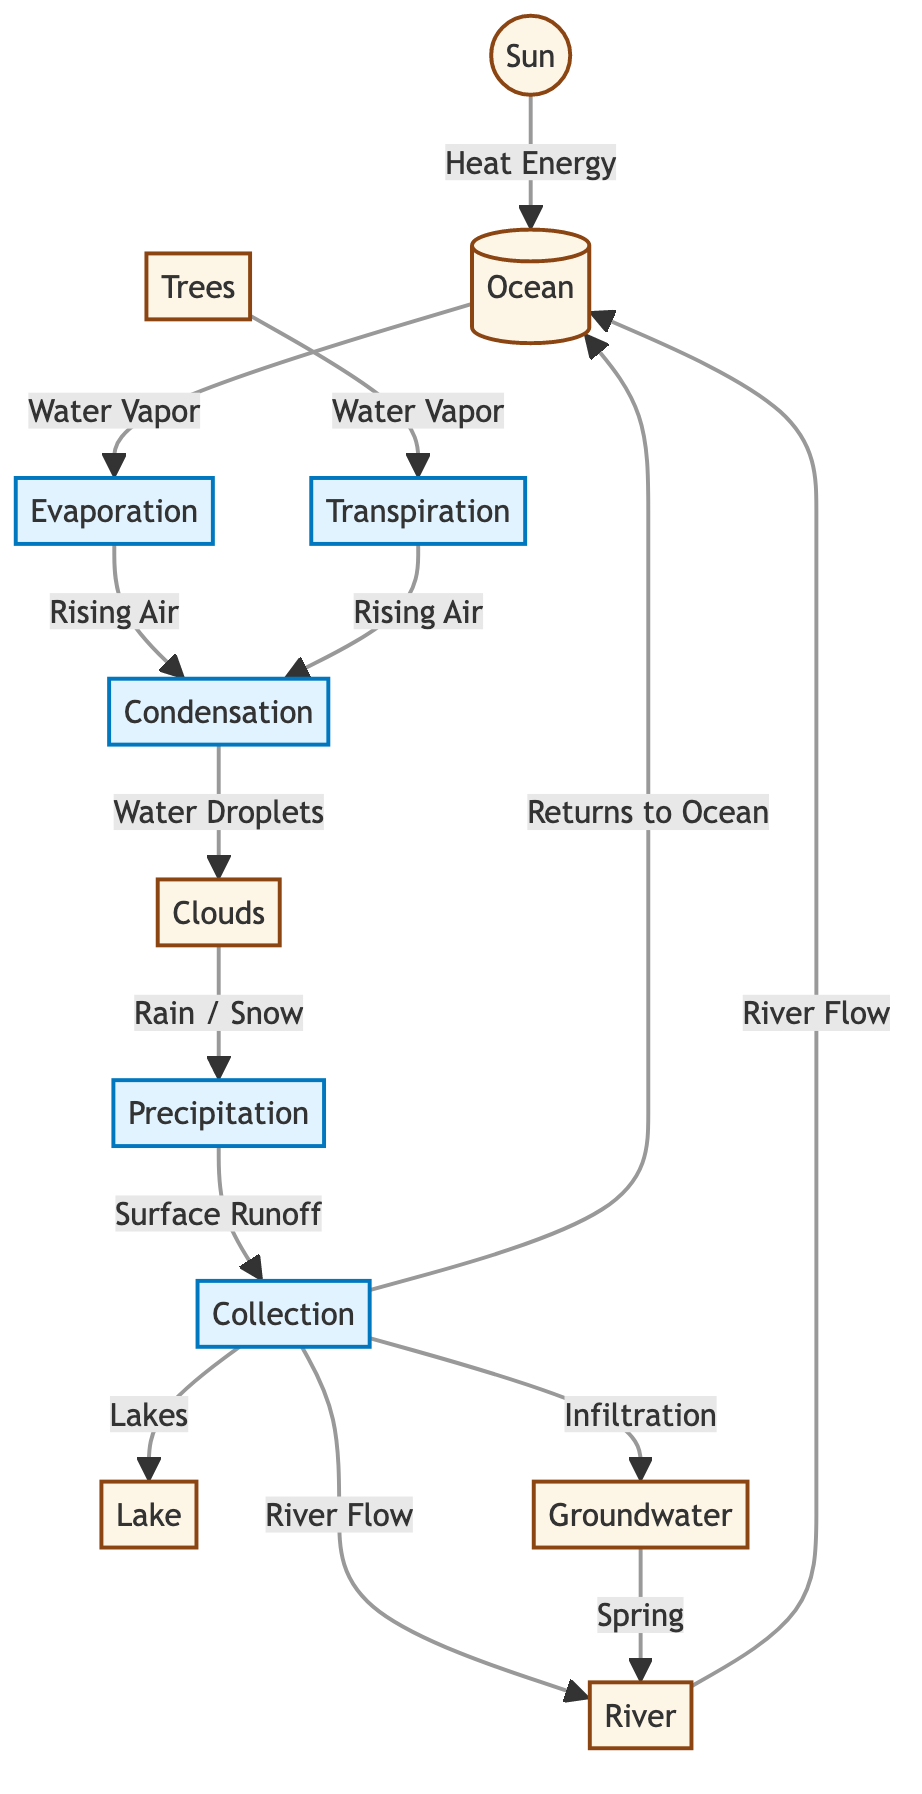What process follows evaporation? According to the diagram, evaporation is followed by condensation, which is indicated by the arrow connecting the two processes.
Answer: condensation How many elements are directly connected to the collection process? The collection process has four direct connections, as seen by the arrows leading to the river, lake, ocean, and groundwater.
Answer: four What does precipitation result in? The precipitation process results in surface runoff, which is denoted by the arrow leading from precipitation to the collection node, indicating the water flows down to this process.
Answer: surface runoff Which element is responsible for transpiration? The element responsible for transpiration is trees, as indicated by the arrow leading from trees to the transpiration process in the diagram.
Answer: trees What does groundwater flow into? Groundwater flows into the river, as illustrated by the arrow going from the groundwater node to the river node, showing a direct connection.
Answer: river What type of energy does the sun provide? The sun provides heat energy, which is explicitly labeled alongside the arrow connecting the sun to the ocean in the diagram.
Answer: heat energy Which two processes are part of the water cycle? The diagram lists several processes, but two notable processes are evaporation and precipitation, clearly labeled in the flow.
Answer: evaporation, precipitation What returns water to the ocean? The collection process returns water to the ocean, as indicated by the arrows pointing to the ocean from the collection node in the diagram.
Answer: collection 